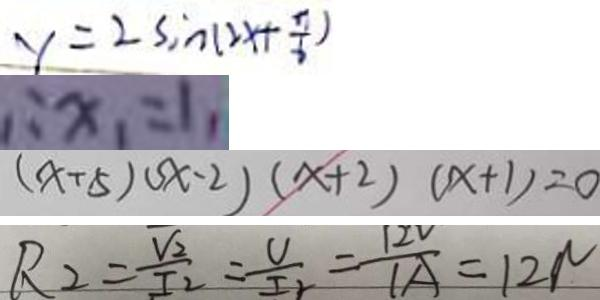<formula> <loc_0><loc_0><loc_500><loc_500>y = 2 \sin ( 2 x + \frac { \pi } { 6 } ) 
 \therefore x _ { 1 } = 1 , 
 ( x + 5 ) s x - 2 ) ( x + 2 ) ( x + 1 ) = 0 
 R _ { 2 } = \frac { V _ { 2 } } { I _ { 2 } } = \frac { V } { I _ { 2 } } = \frac { 1 2 V } { 1 A } = 1 2 N</formula> 